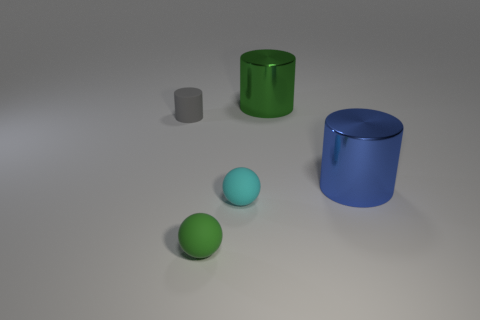What number of blue things are matte blocks or rubber cylinders?
Offer a terse response. 0. There is a big object in front of the small rubber cylinder; how many shiny cylinders are on the left side of it?
Your answer should be very brief. 1. Are there more small matte cylinders that are behind the large blue metallic thing than tiny green rubber objects behind the green matte thing?
Keep it short and to the point. Yes. What is the material of the tiny cyan sphere?
Provide a short and direct response. Rubber. Are there any other cylinders of the same size as the green metallic cylinder?
Provide a succinct answer. Yes. What material is the green thing that is the same size as the blue shiny thing?
Provide a succinct answer. Metal. How many tiny green matte objects are there?
Give a very brief answer. 1. What is the size of the cylinder in front of the small gray rubber cylinder?
Make the answer very short. Large. Is the number of gray cylinders that are on the right side of the small green matte object the same as the number of gray cylinders?
Offer a terse response. No. Is there a large green object that has the same shape as the small gray matte object?
Your answer should be compact. Yes. 